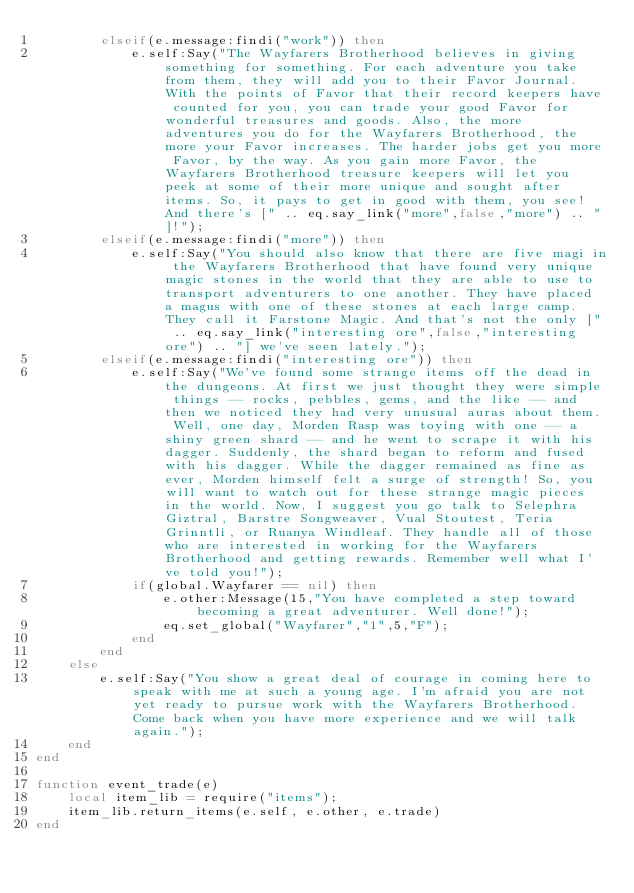<code> <loc_0><loc_0><loc_500><loc_500><_Lua_>		elseif(e.message:findi("work")) then
			e.self:Say("The Wayfarers Brotherhood believes in giving something for something. For each adventure you take from them, they will add you to their Favor Journal. With the points of Favor that their record keepers have counted for you, you can trade your good Favor for wonderful treasures and goods. Also, the more adventures you do for the Wayfarers Brotherhood, the more your Favor increases. The harder jobs get you more Favor, by the way. As you gain more Favor, the Wayfarers Brotherhood treasure keepers will let you peek at some of their more unique and sought after items. So, it pays to get in good with them, you see! And there's [" .. eq.say_link("more",false,"more") .. "]!");
		elseif(e.message:findi("more")) then
			e.self:Say("You should also know that there are five magi in the Wayfarers Brotherhood that have found very unique magic stones in the world that they are able to use to transport adventurers to one another. They have placed a magus with one of these stones at each large camp. They call it Farstone Magic. And that's not the only [" .. eq.say_link("interesting ore",false,"interesting ore") .. "] we've seen lately.");
		elseif(e.message:findi("interesting ore")) then
			e.self:Say("We've found some strange items off the dead in the dungeons. At first we just thought they were simple things -- rocks, pebbles, gems, and the like -- and then we noticed they had very unusual auras about them. Well, one day, Morden Rasp was toying with one -- a shiny green shard -- and he went to scrape it with his dagger. Suddenly, the shard began to reform and fused with his dagger. While the dagger remained as fine as ever, Morden himself felt a surge of strength! So, you will want to watch out for these strange magic pieces in the world. Now, I suggest you go talk to Selephra Giztral, Barstre Songweaver, Vual Stoutest, Teria Grinntli, or Ruanya Windleaf. They handle all of those who are interested in working for the Wayfarers Brotherhood and getting rewards. Remember well what I've told you!");
			if(global.Wayfarer == nil) then
				e.other:Message(15,"You have completed a step toward becoming a great adventurer. Well done!");
				eq.set_global("Wayfarer","1",5,"F");
			end
		end
	else
		e.self:Say("You show a great deal of courage in coming here to speak with me at such a young age. I'm afraid you are not yet ready to pursue work with the Wayfarers Brotherhood.Come back when you have more experience and we will talk again.");
	end
end

function event_trade(e)
	local item_lib = require("items");
	item_lib.return_items(e.self, e.other, e.trade)
end
</code> 